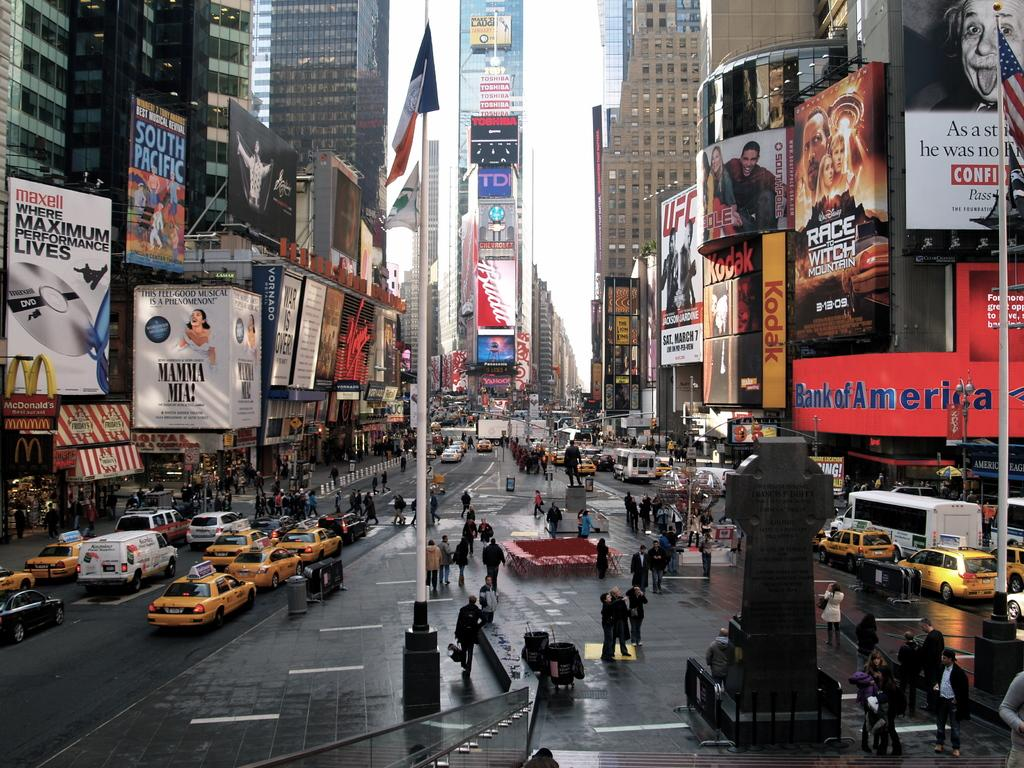<image>
Relay a brief, clear account of the picture shown. a bank of america sign that is outside of a building 